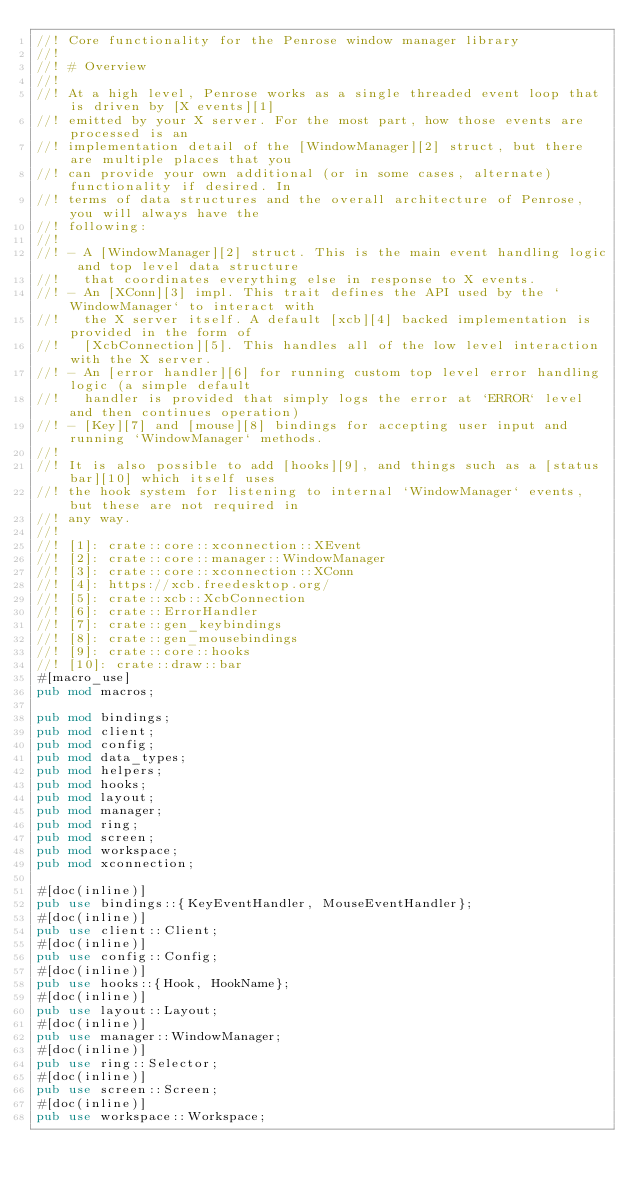Convert code to text. <code><loc_0><loc_0><loc_500><loc_500><_Rust_>//! Core functionality for the Penrose window manager library
//!
//! # Overview
//!
//! At a high level, Penrose works as a single threaded event loop that is driven by [X events][1]
//! emitted by your X server. For the most part, how those events are processed is an
//! implementation detail of the [WindowManager][2] struct, but there are multiple places that you
//! can provide your own additional (or in some cases, alternate) functionality if desired. In
//! terms of data structures and the overall architecture of Penrose, you will always have the
//! following:
//!
//! - A [WindowManager][2] struct. This is the main event handling logic and top level data structure
//!   that coordinates everything else in response to X events.
//! - An [XConn][3] impl. This trait defines the API used by the `WindowManager` to interact with
//!   the X server itself. A default [xcb][4] backed implementation is provided in the form of
//!   [XcbConnection][5]. This handles all of the low level interaction with the X server.
//! - An [error handler][6] for running custom top level error handling logic (a simple default
//!   handler is provided that simply logs the error at `ERROR` level and then continues operation)
//! - [Key][7] and [mouse][8] bindings for accepting user input and running `WindowManager` methods.
//!
//! It is also possible to add [hooks][9], and things such as a [status bar][10] which itself uses
//! the hook system for listening to internal `WindowManager` events, but these are not required in
//! any way.
//!
//! [1]: crate::core::xconnection::XEvent
//! [2]: crate::core::manager::WindowManager
//! [3]: crate::core::xconnection::XConn
//! [4]: https://xcb.freedesktop.org/
//! [5]: crate::xcb::XcbConnection
//! [6]: crate::ErrorHandler
//! [7]: crate::gen_keybindings
//! [8]: crate::gen_mousebindings
//! [9]: crate::core::hooks
//! [10]: crate::draw::bar
#[macro_use]
pub mod macros;

pub mod bindings;
pub mod client;
pub mod config;
pub mod data_types;
pub mod helpers;
pub mod hooks;
pub mod layout;
pub mod manager;
pub mod ring;
pub mod screen;
pub mod workspace;
pub mod xconnection;

#[doc(inline)]
pub use bindings::{KeyEventHandler, MouseEventHandler};
#[doc(inline)]
pub use client::Client;
#[doc(inline)]
pub use config::Config;
#[doc(inline)]
pub use hooks::{Hook, HookName};
#[doc(inline)]
pub use layout::Layout;
#[doc(inline)]
pub use manager::WindowManager;
#[doc(inline)]
pub use ring::Selector;
#[doc(inline)]
pub use screen::Screen;
#[doc(inline)]
pub use workspace::Workspace;
</code> 